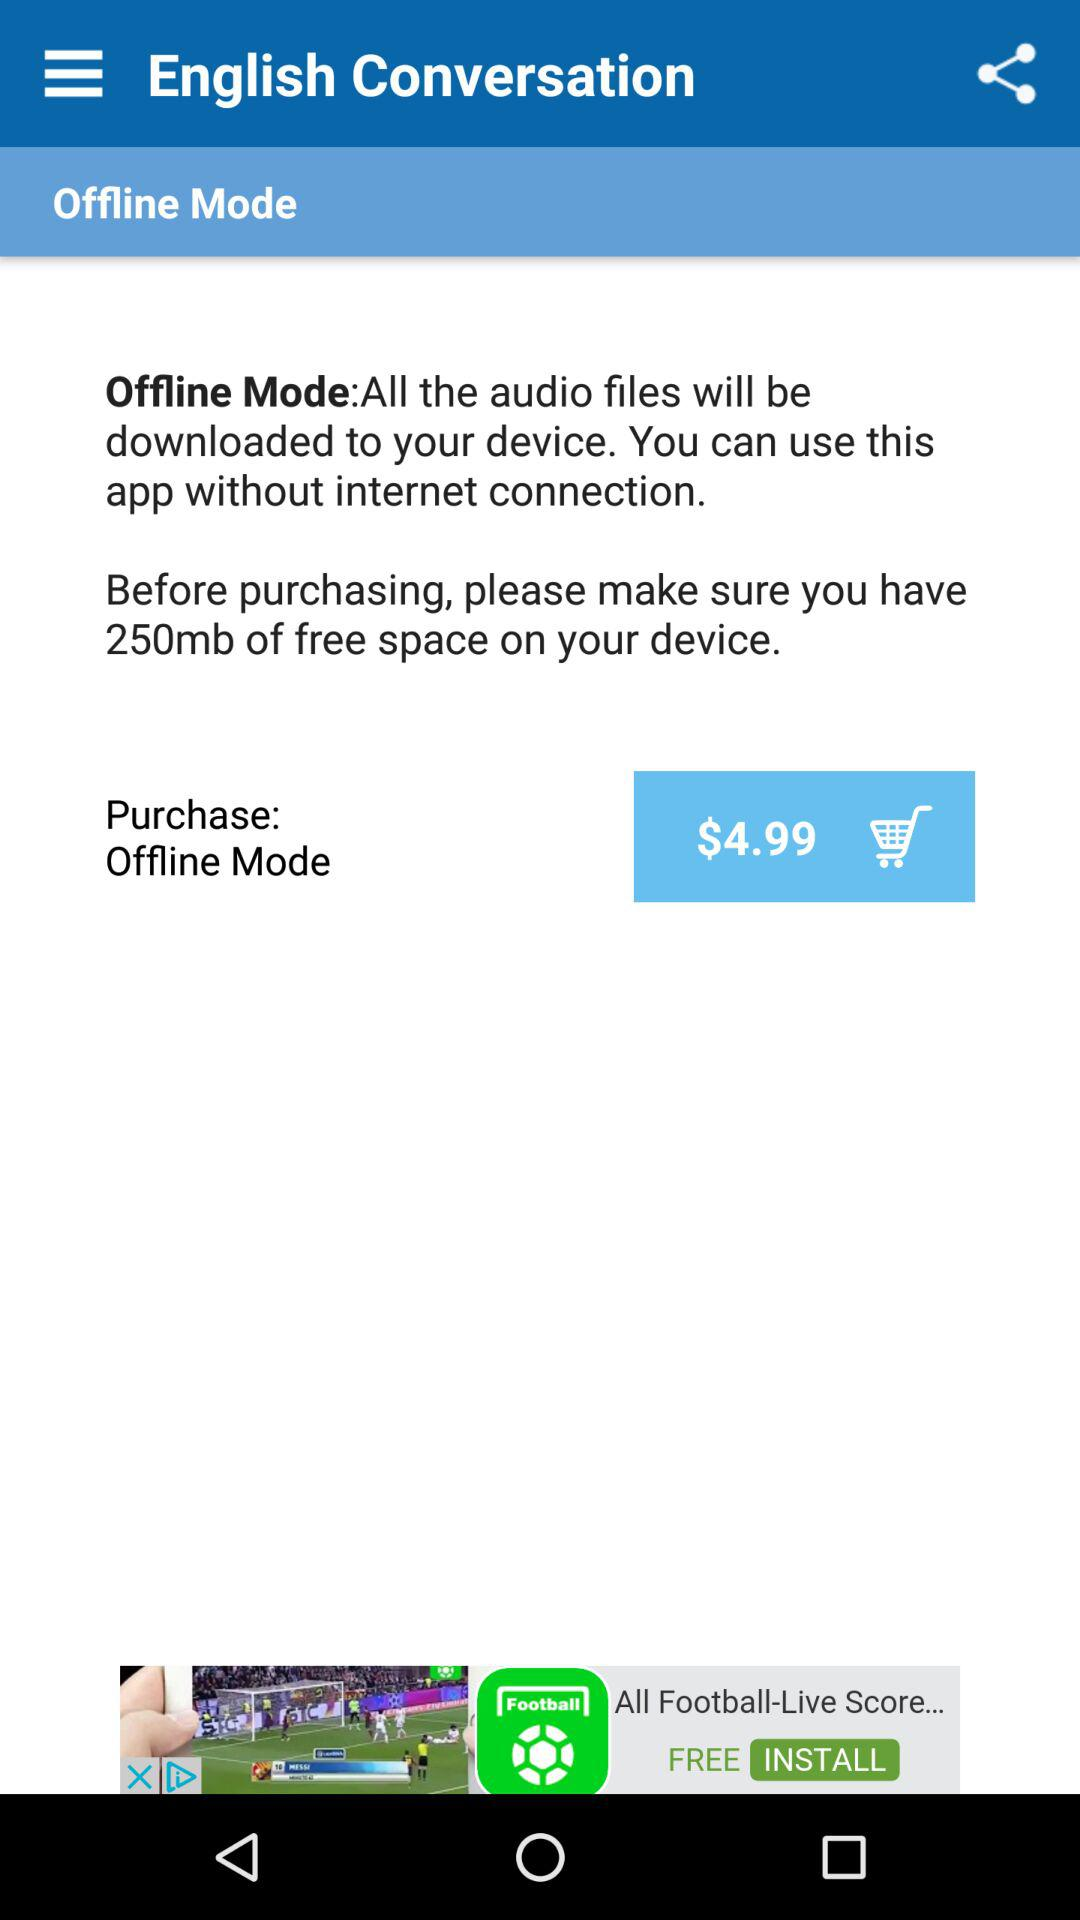How much free space does our device need? Your device needs 250 MB of free space. 